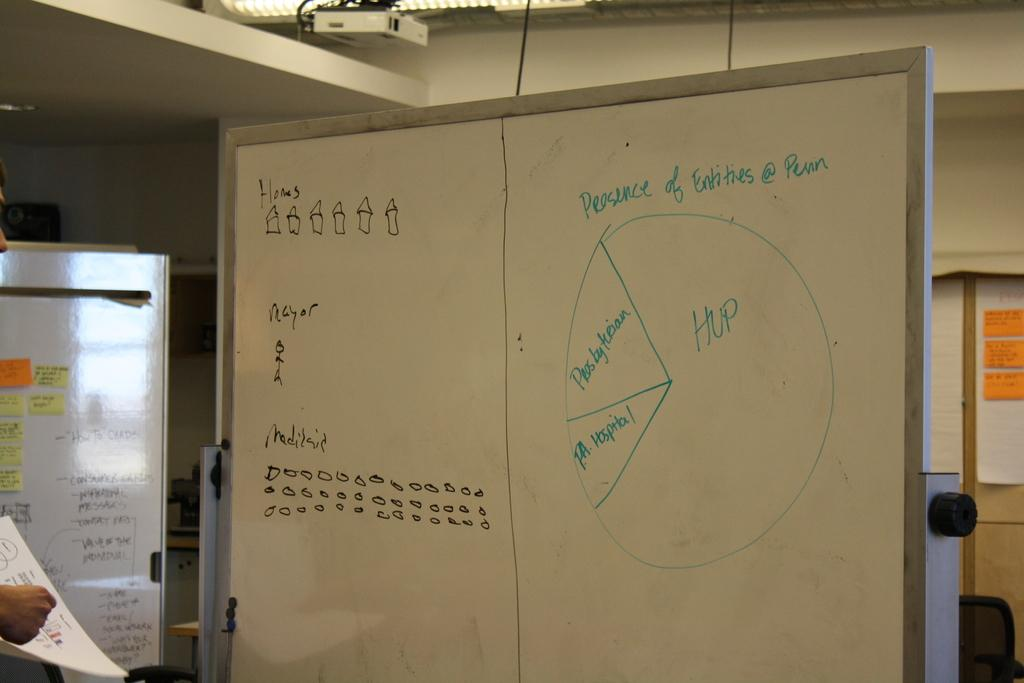<image>
Describe the image concisely. A white board with the words presence of entities written above a pie chart. 